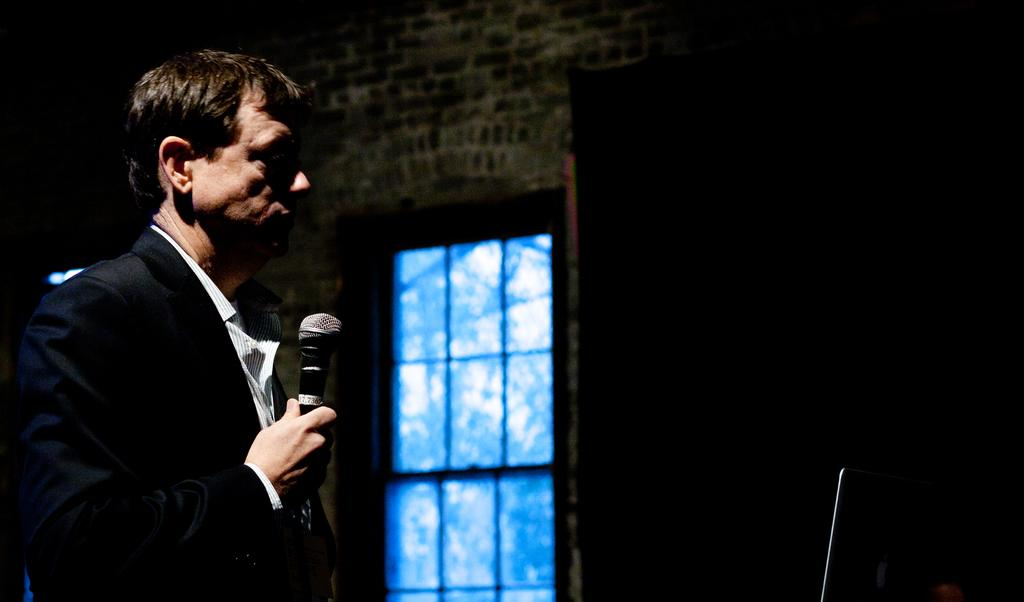What is the man in the image wearing? The man is wearing a black jacket and a white shirt. What is the man holding in his hand? The man is holding a mic in his hand. Where is the man positioned in the image? The man is positioned to the left side of the image. What can be seen on the right side of the image? There is a monitor on the right side of the image. What is in the middle of the image? There is a window in the middle of the image. What type of pet can be seen playing with sticks in the image? There is no pet or sticks present in the image. Is the man wearing a winter coat in the image? The man is wearing a black jacket and a white shirt, but there is no mention of a winter coat in the image. 